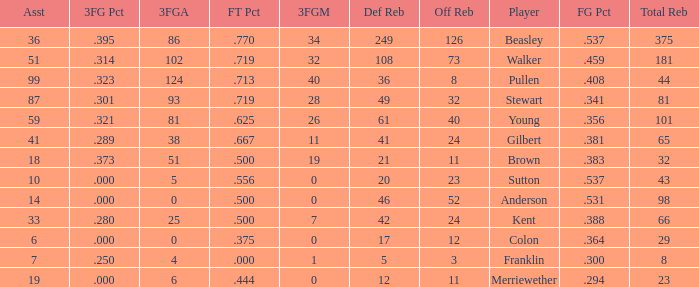What is the total number of offensive rebounds for players with more than 124 3-point attempts? 0.0. 